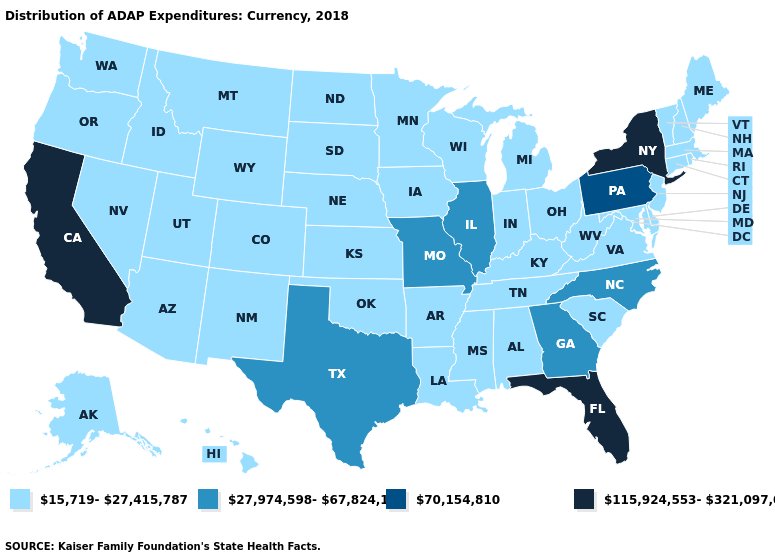What is the value of Missouri?
Concise answer only. 27,974,598-67,824,173. Does Florida have the highest value in the South?
Answer briefly. Yes. What is the value of Mississippi?
Answer briefly. 15,719-27,415,787. Name the states that have a value in the range 27,974,598-67,824,173?
Answer briefly. Georgia, Illinois, Missouri, North Carolina, Texas. Does Louisiana have the lowest value in the South?
Keep it brief. Yes. Does Wisconsin have the highest value in the USA?
Keep it brief. No. What is the value of Nevada?
Be succinct. 15,719-27,415,787. What is the highest value in the USA?
Write a very short answer. 115,924,553-321,097,086. Does the first symbol in the legend represent the smallest category?
Write a very short answer. Yes. Does South Carolina have the lowest value in the USA?
Keep it brief. Yes. Which states have the lowest value in the MidWest?
Concise answer only. Indiana, Iowa, Kansas, Michigan, Minnesota, Nebraska, North Dakota, Ohio, South Dakota, Wisconsin. What is the value of Kansas?
Give a very brief answer. 15,719-27,415,787. What is the value of Pennsylvania?
Write a very short answer. 70,154,810. Name the states that have a value in the range 70,154,810?
Short answer required. Pennsylvania. Does the map have missing data?
Quick response, please. No. 